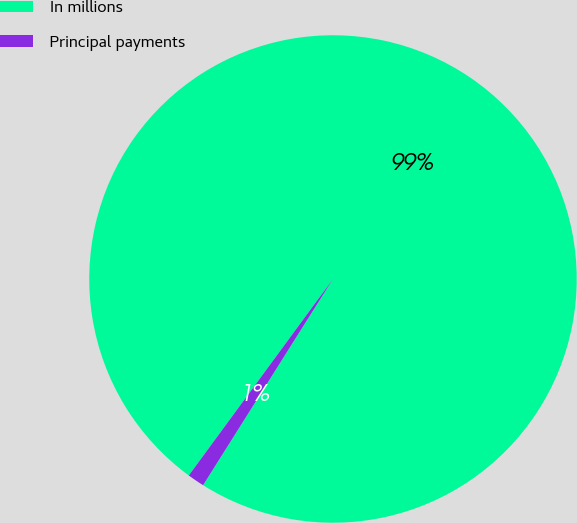<chart> <loc_0><loc_0><loc_500><loc_500><pie_chart><fcel>In millions<fcel>Principal payments<nl><fcel>98.87%<fcel>1.13%<nl></chart> 